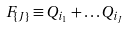<formula> <loc_0><loc_0><loc_500><loc_500>F _ { \{ J \} } \equiv Q _ { i _ { 1 } } + \dots Q _ { i _ { J } }</formula> 